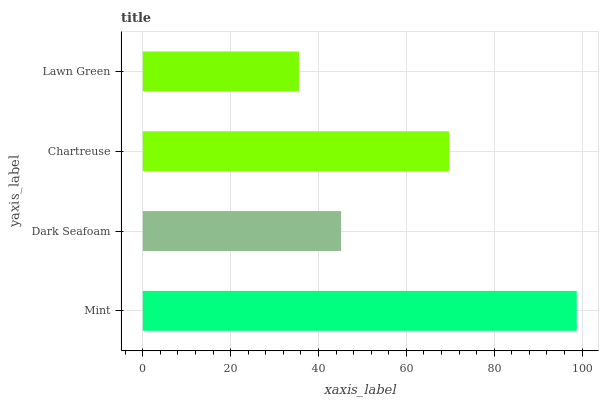Is Lawn Green the minimum?
Answer yes or no. Yes. Is Mint the maximum?
Answer yes or no. Yes. Is Dark Seafoam the minimum?
Answer yes or no. No. Is Dark Seafoam the maximum?
Answer yes or no. No. Is Mint greater than Dark Seafoam?
Answer yes or no. Yes. Is Dark Seafoam less than Mint?
Answer yes or no. Yes. Is Dark Seafoam greater than Mint?
Answer yes or no. No. Is Mint less than Dark Seafoam?
Answer yes or no. No. Is Chartreuse the high median?
Answer yes or no. Yes. Is Dark Seafoam the low median?
Answer yes or no. Yes. Is Dark Seafoam the high median?
Answer yes or no. No. Is Mint the low median?
Answer yes or no. No. 